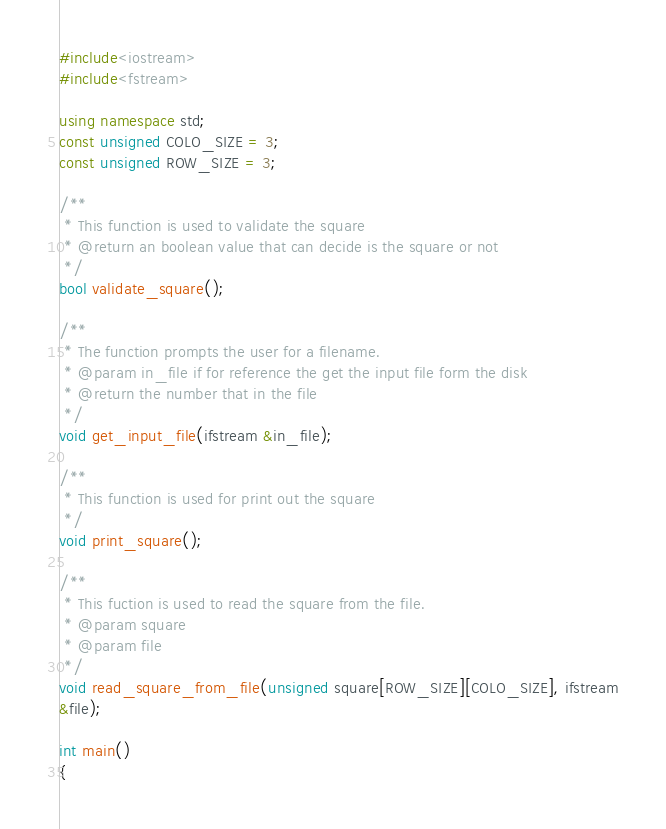Convert code to text. <code><loc_0><loc_0><loc_500><loc_500><_C++_>#include<iostream>
#include<fstream>

using namespace std;
const unsigned COLO_SIZE = 3;
const unsigned ROW_SIZE = 3;

/**
 * This function is used to validate the square
 * @return an boolean value that can decide is the square or not
 */
bool validate_square();

/**
 * The function prompts the user for a filename.
 * @param in_file if for reference the get the input file form the disk
 * @return the number that in the file
 */
void get_input_file(ifstream &in_file);

/**
 * This function is used for print out the square
 */
void print_square();

/**
 * This fuction is used to read the square from the file.
 * @param square
 * @param file
 */
void read_square_from_file(unsigned square[ROW_SIZE][COLO_SIZE], ifstream
&file);

int main()
{</code> 